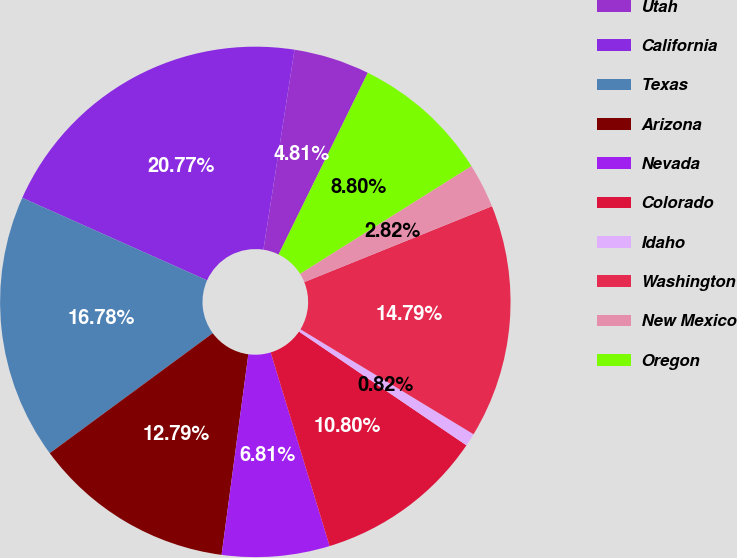<chart> <loc_0><loc_0><loc_500><loc_500><pie_chart><fcel>Utah<fcel>California<fcel>Texas<fcel>Arizona<fcel>Nevada<fcel>Colorado<fcel>Idaho<fcel>Washington<fcel>New Mexico<fcel>Oregon<nl><fcel>4.81%<fcel>20.77%<fcel>16.78%<fcel>12.79%<fcel>6.81%<fcel>10.8%<fcel>0.82%<fcel>14.79%<fcel>2.82%<fcel>8.8%<nl></chart> 